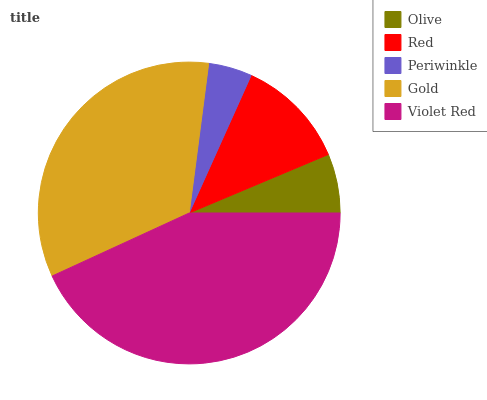Is Periwinkle the minimum?
Answer yes or no. Yes. Is Violet Red the maximum?
Answer yes or no. Yes. Is Red the minimum?
Answer yes or no. No. Is Red the maximum?
Answer yes or no. No. Is Red greater than Olive?
Answer yes or no. Yes. Is Olive less than Red?
Answer yes or no. Yes. Is Olive greater than Red?
Answer yes or no. No. Is Red less than Olive?
Answer yes or no. No. Is Red the high median?
Answer yes or no. Yes. Is Red the low median?
Answer yes or no. Yes. Is Violet Red the high median?
Answer yes or no. No. Is Olive the low median?
Answer yes or no. No. 